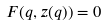<formula> <loc_0><loc_0><loc_500><loc_500>F ( q , z ( q ) ) = 0</formula> 